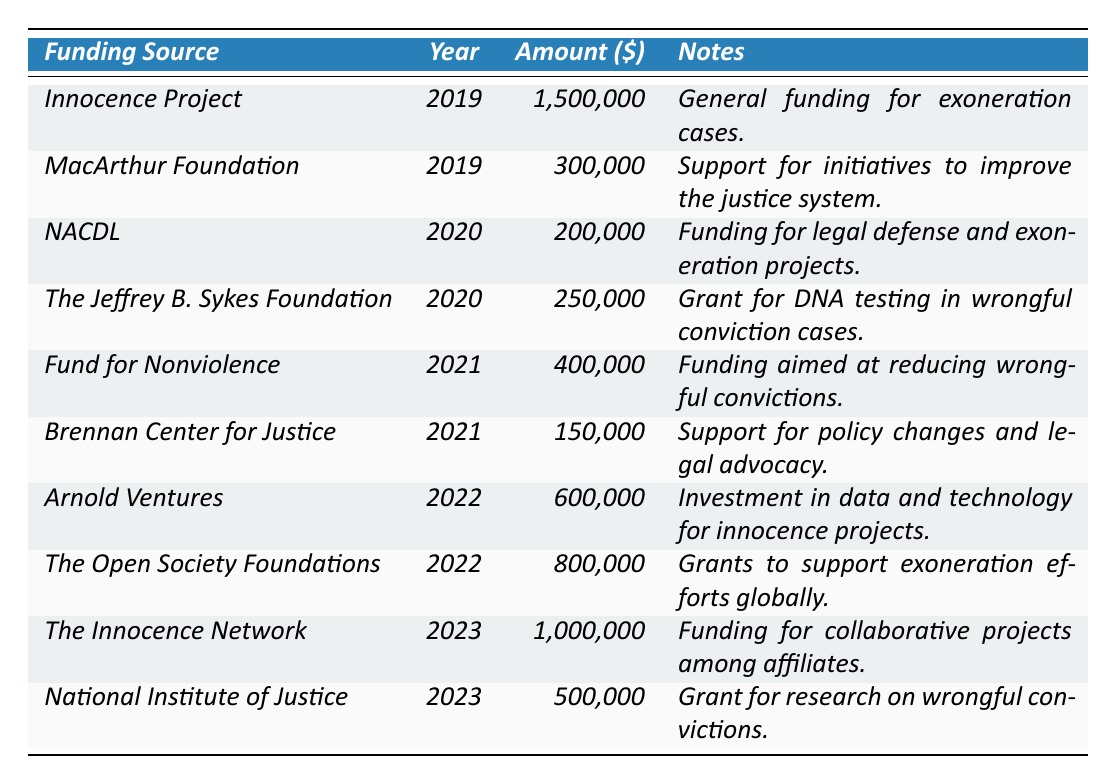What is the total amount allocated in 2020? In 2020, the funding sources were NACDL with 200,000 and The Jeffrey B. Sykes Foundation with 250,000. Adding them together gives 200,000 + 250,000 = 450,000.
Answer: 450,000 Which funding source provided the highest amount in 2022? In 2022, the funding sources were Arnold Ventures with 600,000 and The Open Society Foundations with 800,000. The higher amount between these is 800,000 from The Open Society Foundations.
Answer: The Open Society Foundations Did the amount allocated increase or decrease from 2019 to 2023? In 2019, the total amount was 1,500,000 and in 2023, it was 1,500,000 (1,000,000 from The Innocence Network and 500,000 from National Institute of Justice). Since 1,500,000 is the same as 1,500,000, it neither increased nor decreased.
Answer: No What percentage of the total funding in 2021 was allocated by the Fund for Nonviolence? In 2021, the total funding amounts were 400,000 from Fund for Nonviolence and 150,000 from Brennan Center for Justice. Adding these gives 400,000 + 150,000 = 550,000. The percentage for Fund for Nonviolence is (400,000 / 550,000) * 100 = 72.73%.
Answer: 72.73% Which organization contributed to funding in both 2019 and 2021? The Innocence Project provided funding in 2019 and no funded organization appears in 2021 besides the other organizations. Therefore, none of the organizations contributed in both years.
Answer: None What was the total amount allocated over the years 2019 to 2023? The total sum from all years is 1,500,000 (2019) + 300,000 (2019) + 200,000 (2020) + 250,000 (2020) + 400,000 (2021) + 150,000 (2021) + 600,000 (2022) + 800,000 (2022) + 1,000,000 (2023) + 500,000 (2023) = 5,250,000.
Answer: 5,250,000 How does the funding from The Open Society Foundations compare to the total funding from all other sources in 2022? The Open Society Foundations allocated 800,000 in 2022. The total from Arnold Ventures and Open Society Foundations is 800,000 + 600,000 = 1,400,000. Since 800,000 is less than 1,400,000, it is less than the total from other sources.
Answer: Less than 